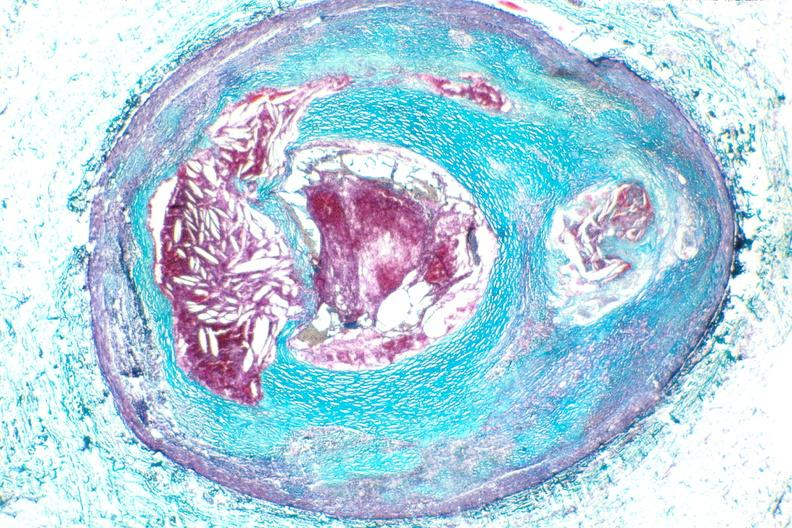what does this image show?
Answer the question using a single word or phrase. Right coronary artery 